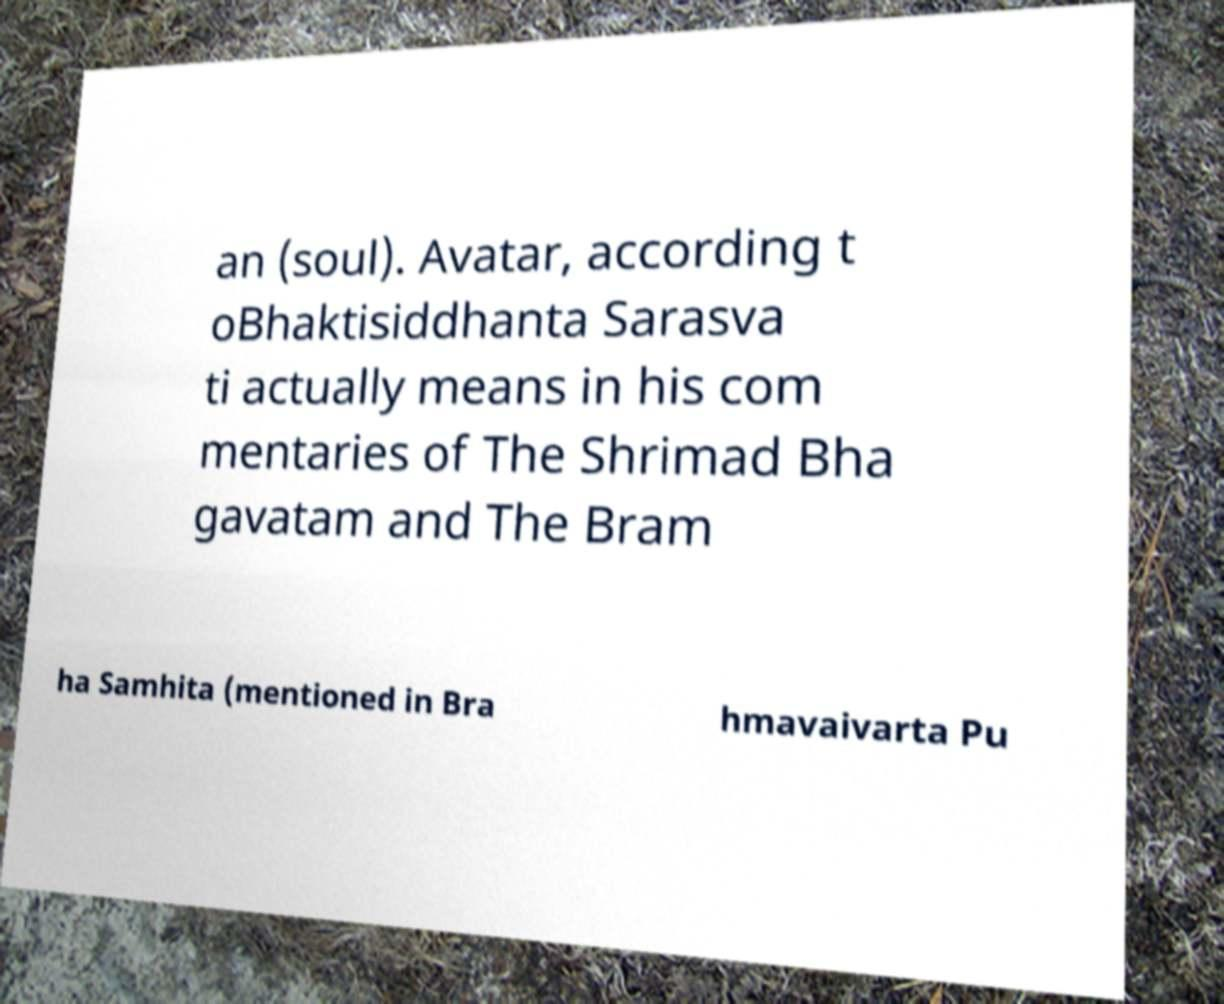Please read and relay the text visible in this image. What does it say? an (soul). Avatar, according t oBhaktisiddhanta Sarasva ti actually means in his com mentaries of The Shrimad Bha gavatam and The Bram ha Samhita (mentioned in Bra hmavaivarta Pu 